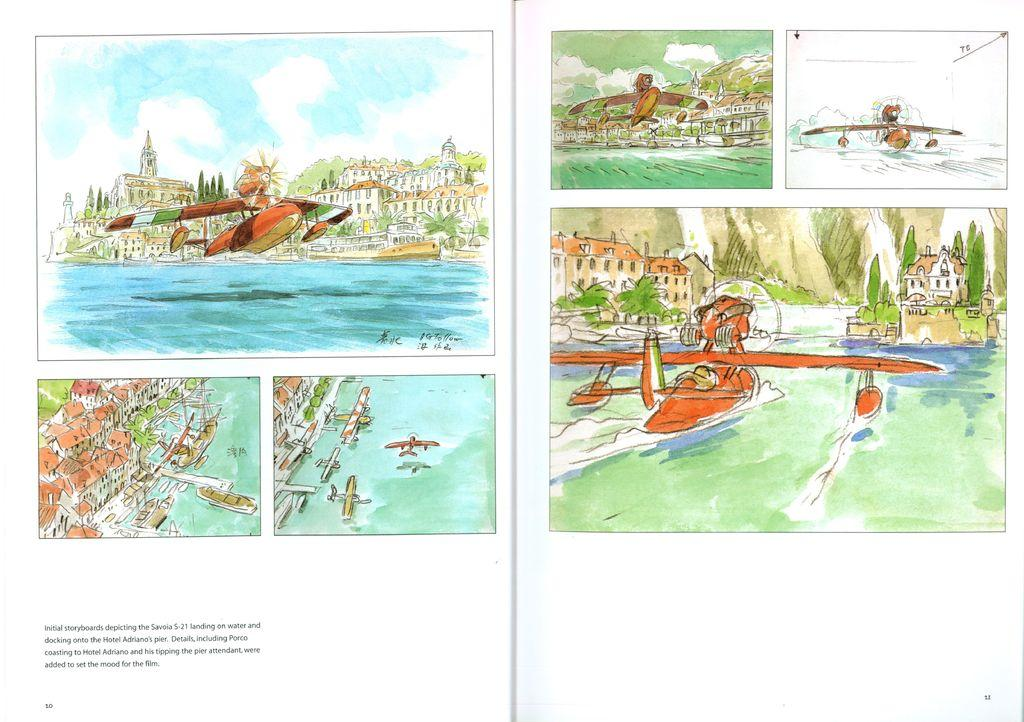What type of content is present in the book in the image? There are painted images in the book. Can you describe any other elements in the image besides the book? Yes, there is text in the bottom left hand side of the image. How many legs can be seen on the duck in the image? There is no duck present in the image, so it is not possible to determine the number of legs. 